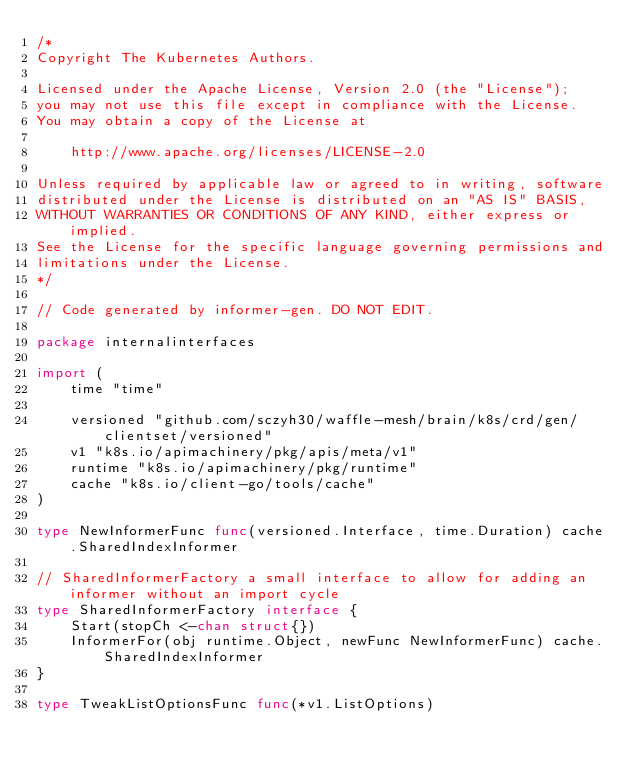Convert code to text. <code><loc_0><loc_0><loc_500><loc_500><_Go_>/*
Copyright The Kubernetes Authors.

Licensed under the Apache License, Version 2.0 (the "License");
you may not use this file except in compliance with the License.
You may obtain a copy of the License at

    http://www.apache.org/licenses/LICENSE-2.0

Unless required by applicable law or agreed to in writing, software
distributed under the License is distributed on an "AS IS" BASIS,
WITHOUT WARRANTIES OR CONDITIONS OF ANY KIND, either express or implied.
See the License for the specific language governing permissions and
limitations under the License.
*/

// Code generated by informer-gen. DO NOT EDIT.

package internalinterfaces

import (
	time "time"

	versioned "github.com/sczyh30/waffle-mesh/brain/k8s/crd/gen/clientset/versioned"
	v1 "k8s.io/apimachinery/pkg/apis/meta/v1"
	runtime "k8s.io/apimachinery/pkg/runtime"
	cache "k8s.io/client-go/tools/cache"
)

type NewInformerFunc func(versioned.Interface, time.Duration) cache.SharedIndexInformer

// SharedInformerFactory a small interface to allow for adding an informer without an import cycle
type SharedInformerFactory interface {
	Start(stopCh <-chan struct{})
	InformerFor(obj runtime.Object, newFunc NewInformerFunc) cache.SharedIndexInformer
}

type TweakListOptionsFunc func(*v1.ListOptions)
</code> 